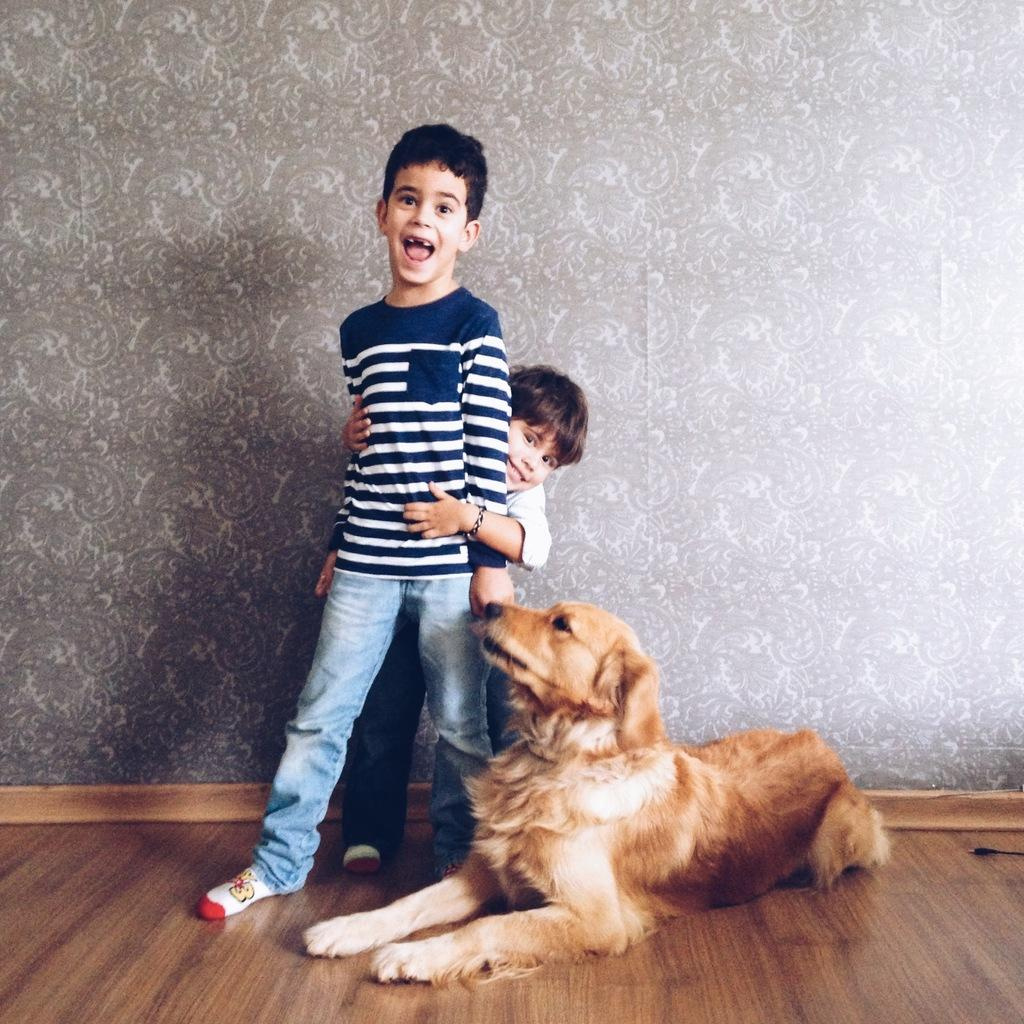How many kids are present in the image? There are two kids in the image. What are the kids doing in the image? The kids are standing together. What other living creature is present in the image? There is a dog in the image. What is the position of the dog in the image? The dog is resting on the ground. What can be seen in the background of the image? There is a wall in the background of the image. What type of wound can be seen on the dog's paw in the image? There is no wound visible on the dog's paw in the image. What color is the sock worn by the dog in the image? There is no sock worn by the dog in the image, as dogs do not wear socks. 